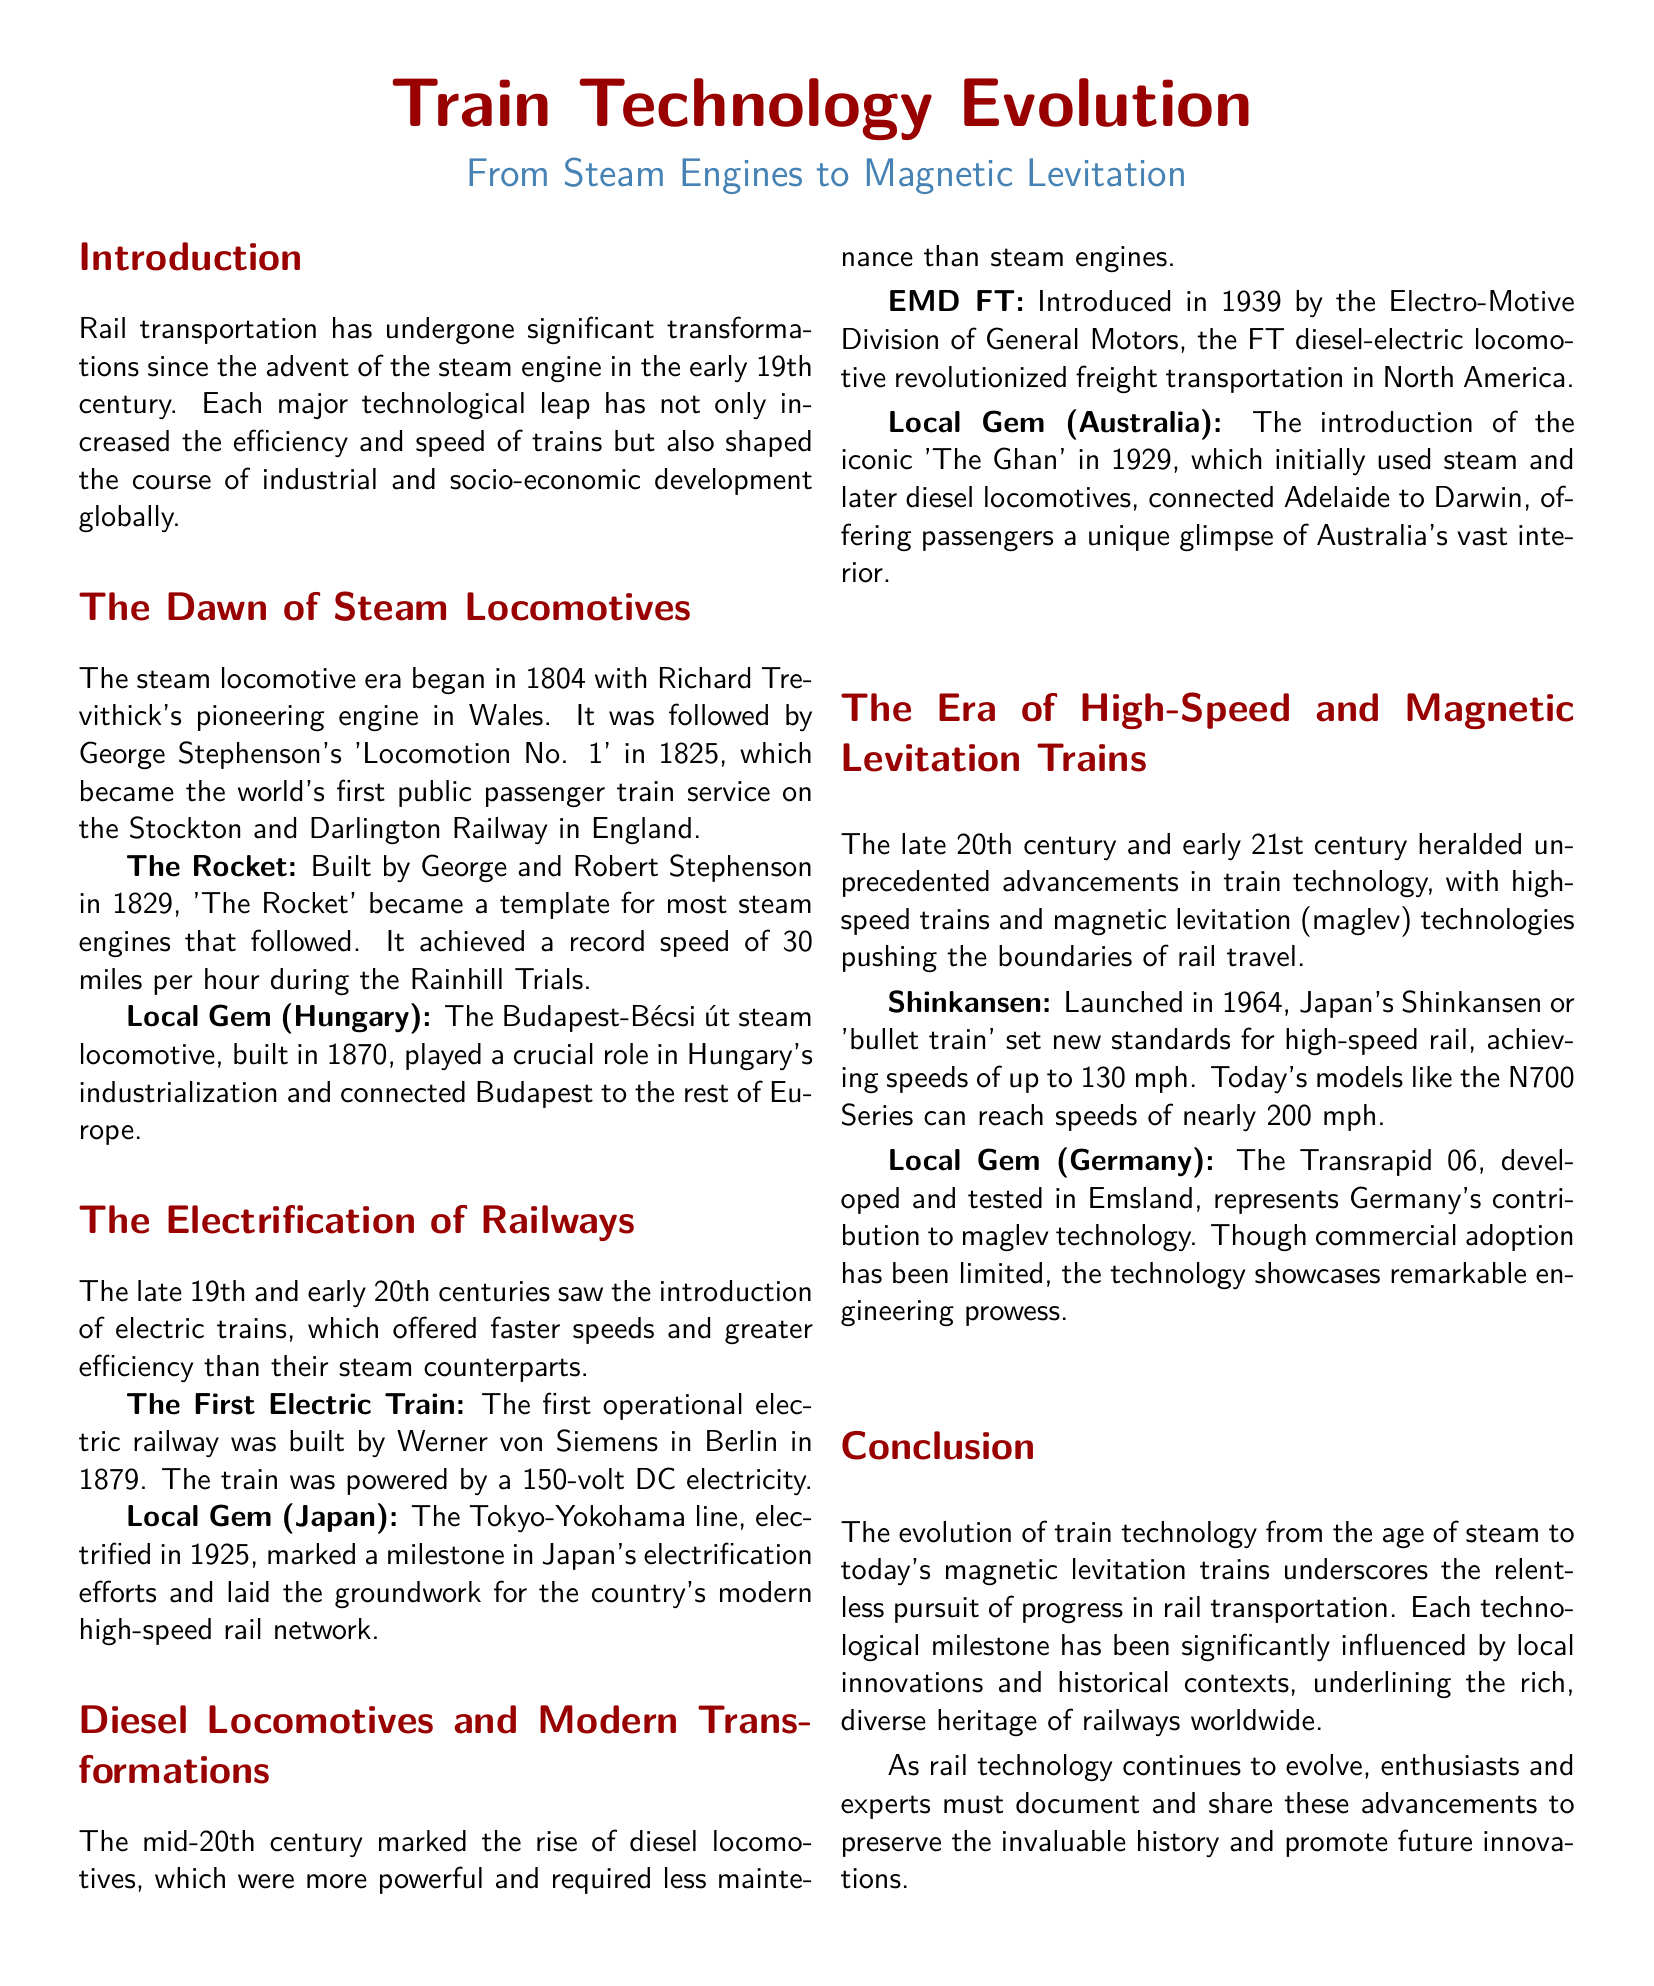What year did Richard Trevithick build the first steam locomotive? The document states that Richard Trevithick's pioneering engine began the steam locomotive era in 1804.
Answer: 1804 Which train became the first public passenger train service? The document mentions George Stephenson's 'Locomotion No. 1' in 1825 as the world's first public passenger train service.
Answer: Locomotion No. 1 What is the significance of the Budapest-Bécsi út steam locomotive? The document highlights that it played a crucial role in Hungary's industrialization and connected Budapest to the rest of Europe.
Answer: Industrialization What was the first operational electric railway? The document provides information that the first operational electric railway was built by Werner von Siemens in Berlin in 1879.
Answer: Berlin What year did Japan's Shinkansen launch? According to the document, Japan's Shinkansen or 'bullet train' was launched in 1964.
Answer: 1964 Which train model revolutionized freight transportation in North America? The document specifies that the EMD FT diesel-electric locomotive, introduced in 1939, revolutionized freight transportation.
Answer: EMD FT How fast can today's Shinkansen models reach? The document states that today's models like the N700 Series can reach speeds of nearly 200 mph.
Answer: 200 mph What does the Transrapid 06 represent? The document mentions that the Transrapid 06 represents Germany's contribution to maglev technology.
Answer: Maglev technology What key aspect does the conclusion emphasize about train technology? The conclusion points out the relentless pursuit of progress in rail transportation as a key aspect of train technology evolution.
Answer: Progress 